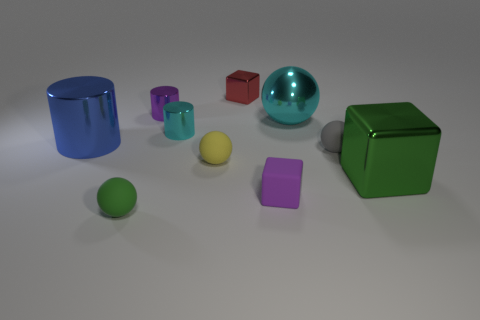Is the tiny purple thing behind the large green metallic thing made of the same material as the small gray sphere?
Give a very brief answer. No. The small rubber ball to the right of the matte block is what color?
Keep it short and to the point. Gray. Are there any blue metal things that have the same size as the green metallic block?
Offer a terse response. Yes. There is a green sphere that is the same size as the gray rubber thing; what is it made of?
Provide a short and direct response. Rubber. Do the purple metallic thing and the rubber ball behind the small yellow matte ball have the same size?
Ensure brevity in your answer.  Yes. There is a small thing that is right of the tiny purple cube; what is it made of?
Offer a terse response. Rubber. Is the number of blue metallic objects on the right side of the tiny yellow sphere the same as the number of big gray metallic objects?
Give a very brief answer. Yes. Is the size of the green block the same as the blue cylinder?
Your answer should be very brief. Yes. There is a small rubber ball in front of the block that is on the right side of the large shiny sphere; are there any cylinders to the left of it?
Your answer should be very brief. Yes. There is a cyan thing that is the same shape as the big blue object; what is it made of?
Keep it short and to the point. Metal. 